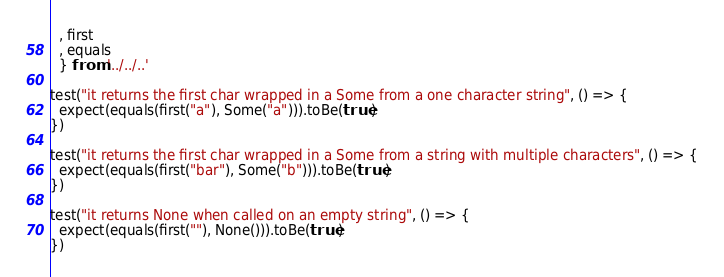<code> <loc_0><loc_0><loc_500><loc_500><_JavaScript_>  , first
  , equals
  } from '../../..'

test("it returns the first char wrapped in a Some from a one character string", () => {
  expect(equals(first("a"), Some("a"))).toBe(true)
})

test("it returns the first char wrapped in a Some from a string with multiple characters", () => {
  expect(equals(first("bar"), Some("b"))).toBe(true)
})

test("it returns None when called on an empty string", () => {
  expect(equals(first(""), None())).toBe(true)
})</code> 